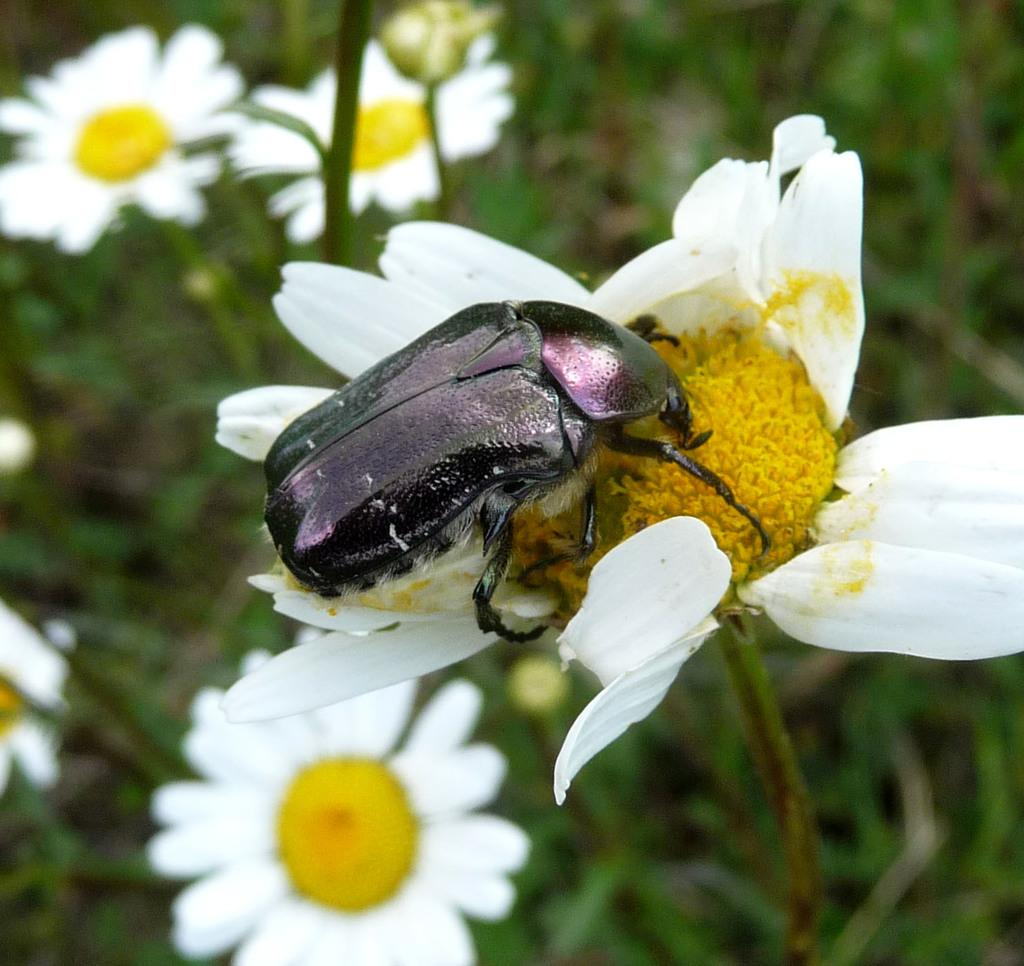What is the main subject of the image? There is a small bee in the image. What is the bee doing in the image? The bee is eating pollen grains. What can be seen in the background of the image? There are white flowers in the background of the image. Where are the flowers located? The flowers are on a plant. What type of steel is used to construct the front of the bee in the image? There is no steel or front of the bee present in the image, as it is a photograph of a real bee. 